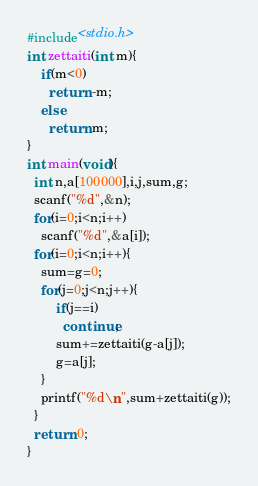Convert code to text. <code><loc_0><loc_0><loc_500><loc_500><_C_>#include<stdio.h>
int zettaiti(int m){
	if(m<0)
      return -m;
  	else
      return m;
}
int main(void){
  int n,a[100000],i,j,sum,g;
  scanf("%d",&n);
  for(i=0;i<n;i++)
    scanf("%d",&a[i]);
  for(i=0;i<n;i++){
    sum=g=0;
    for(j=0;j<n;j++){
      	if(j==i)
          continue;
  		sum+=zettaiti(g-a[j]);
      	g=a[j];
    }
    printf("%d\n",sum+zettaiti(g));
  }
  return 0;
}</code> 